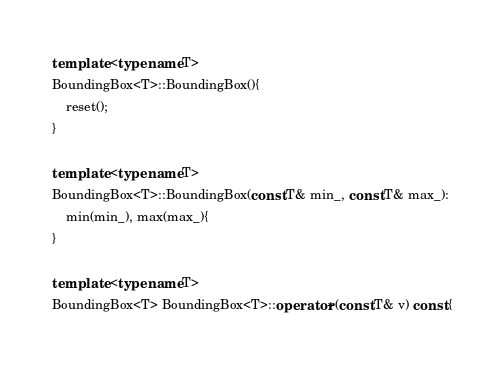<code> <loc_0><loc_0><loc_500><loc_500><_C++_>template <typename T>
BoundingBox<T>::BoundingBox(){
	reset();
}

template <typename T>
BoundingBox<T>::BoundingBox(const T& min_, const T& max_):
	min(min_), max(max_){
}

template <typename T>
BoundingBox<T> BoundingBox<T>::operator+(const T& v) const {
</code> 